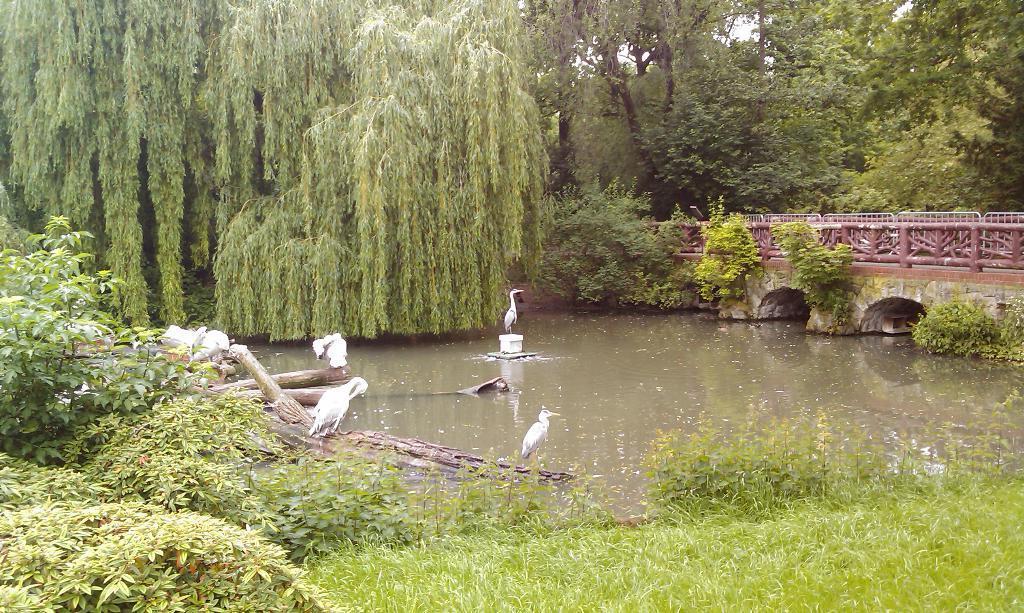How would you summarize this image in a sentence or two? In this picture we can see few birds. A bird is standing on a white object in water. We can see wooden logs. There are few trees. We can see some fencing and arches on the right side. Some grass is visible on bottom right. 